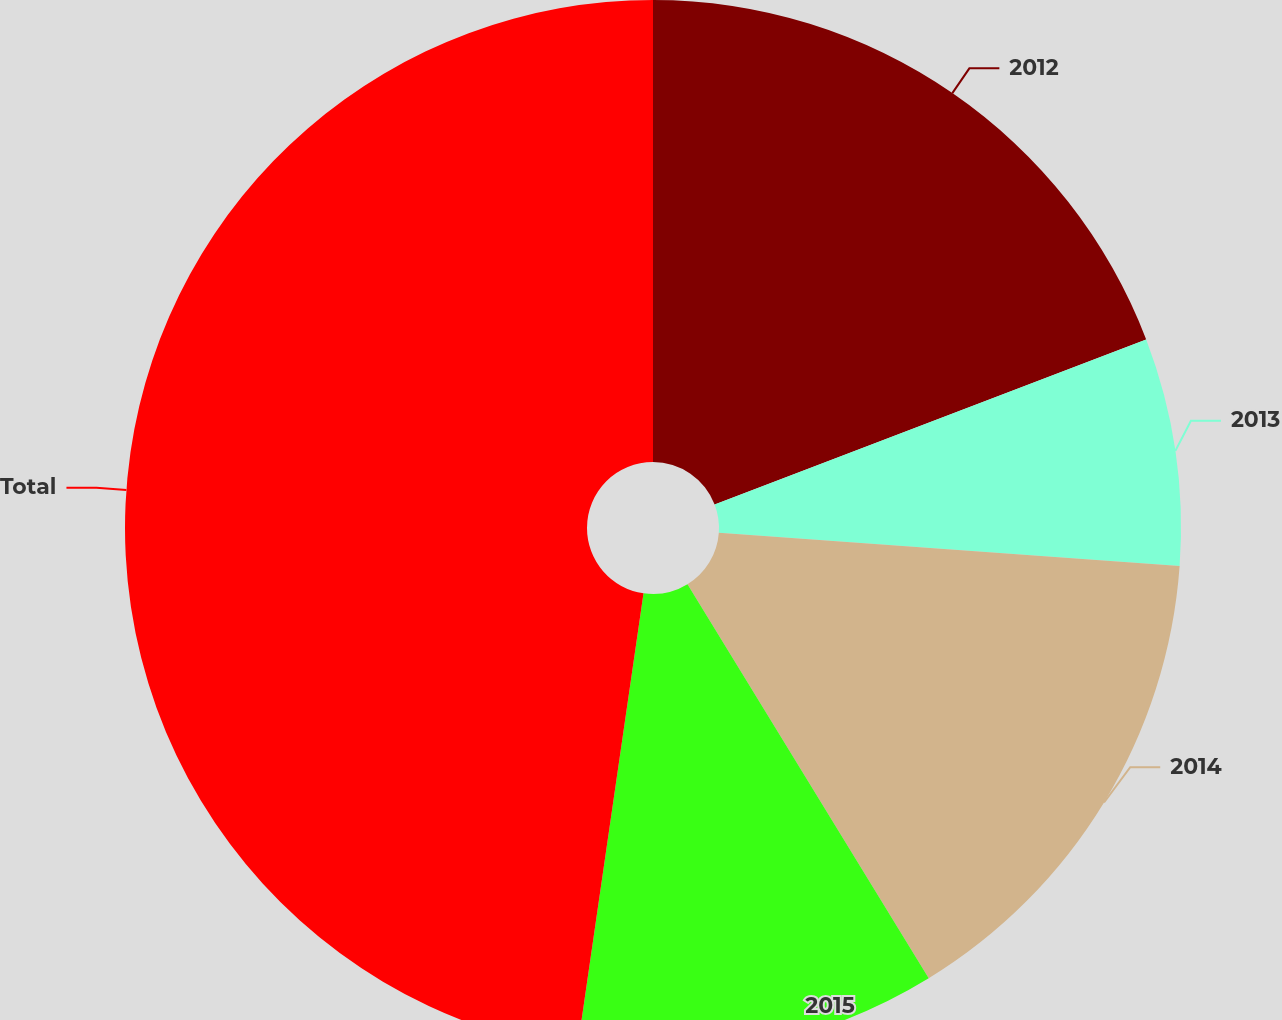Convert chart. <chart><loc_0><loc_0><loc_500><loc_500><pie_chart><fcel>2012<fcel>2013<fcel>2014<fcel>2015<fcel>Total<nl><fcel>19.19%<fcel>6.96%<fcel>15.11%<fcel>11.04%<fcel>47.71%<nl></chart> 